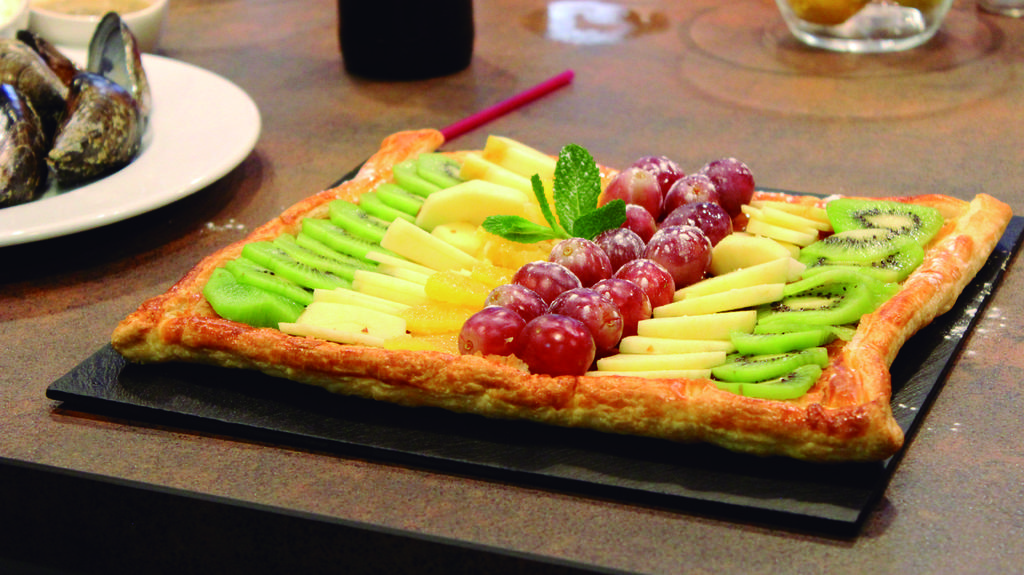What piece of furniture is present in the image? There is a table in the image. What is placed on the table? There are many platters and plates on the table. What can be found on the platters and plates? There is food on the platters and plates. What else is on the table besides the platters and plates? There are glasses on the table. What is inside the glasses? There is drink in the glasses. What type of lawyer is sitting on the shelf in the image? There is no lawyer or shelf present in the image. How does the behavior of the food on the platters and plates change throughout the day in the image? The behavior of the food on the platters and plates does not change throughout the day in the image, as it is a still image. 